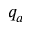Convert formula to latex. <formula><loc_0><loc_0><loc_500><loc_500>q _ { a }</formula> 